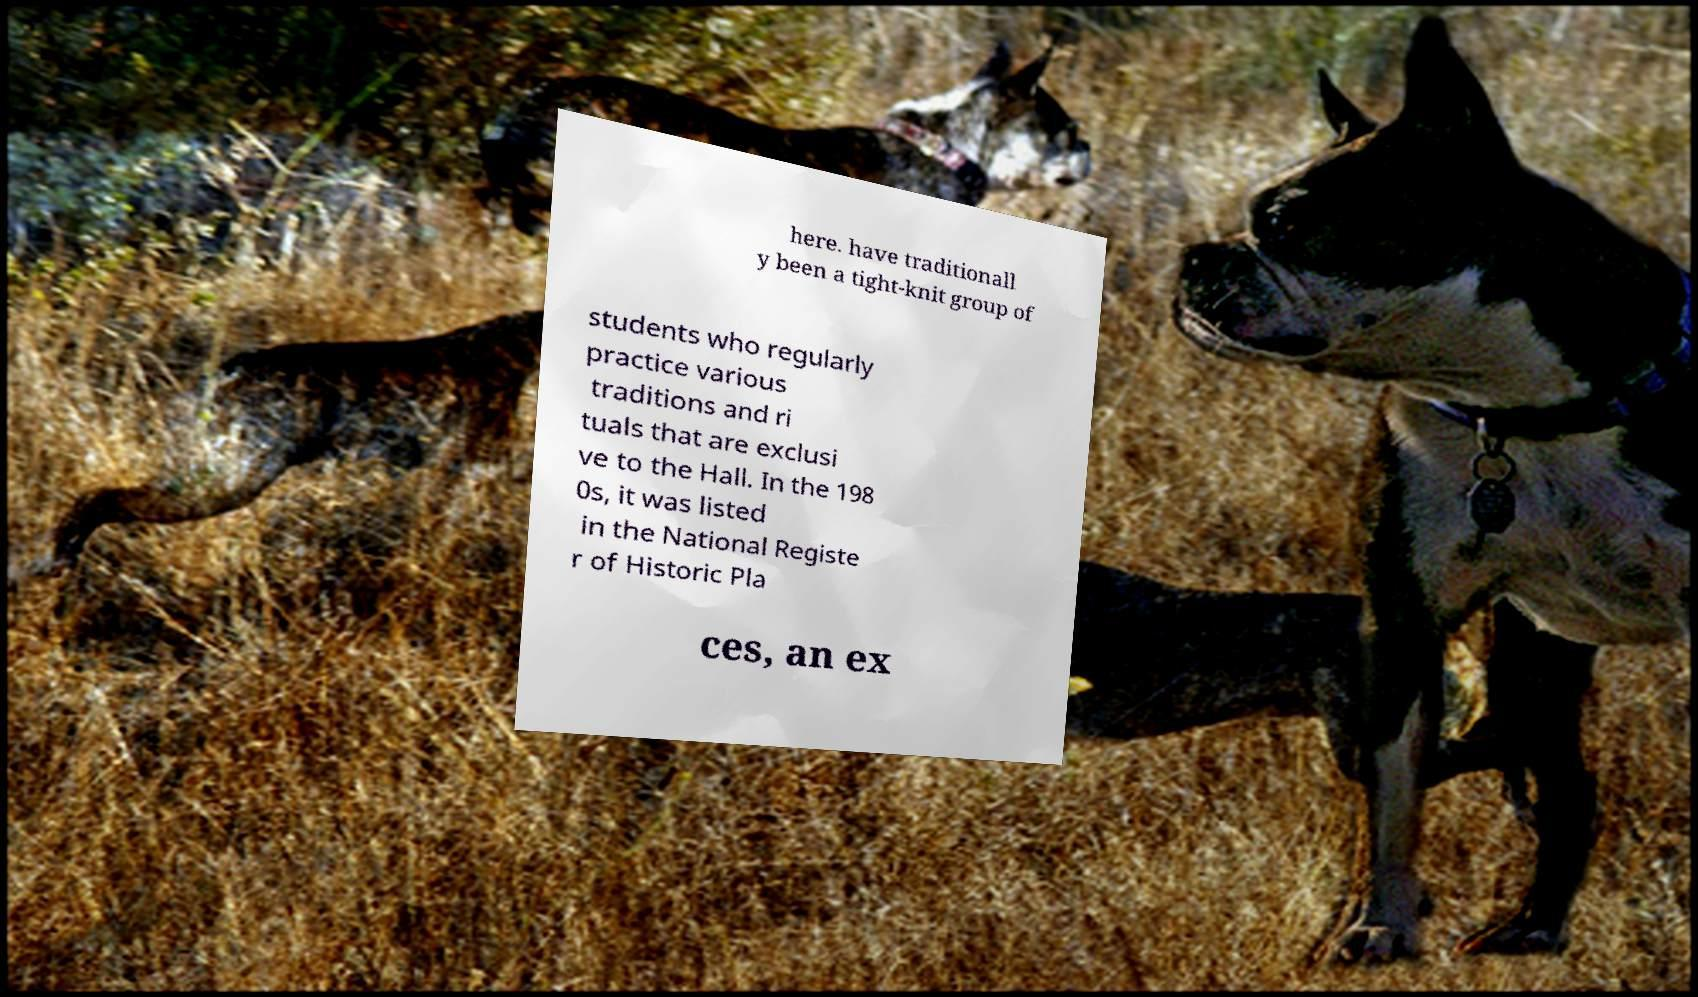Can you accurately transcribe the text from the provided image for me? here. have traditionall y been a tight-knit group of students who regularly practice various traditions and ri tuals that are exclusi ve to the Hall. In the 198 0s, it was listed in the National Registe r of Historic Pla ces, an ex 